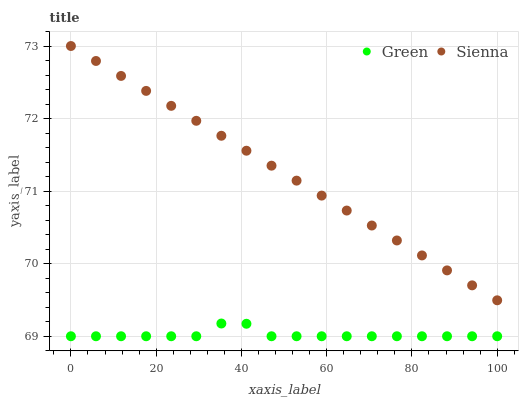Does Green have the minimum area under the curve?
Answer yes or no. Yes. Does Sienna have the maximum area under the curve?
Answer yes or no. Yes. Does Green have the maximum area under the curve?
Answer yes or no. No. Is Sienna the smoothest?
Answer yes or no. Yes. Is Green the roughest?
Answer yes or no. Yes. Is Green the smoothest?
Answer yes or no. No. Does Green have the lowest value?
Answer yes or no. Yes. Does Sienna have the highest value?
Answer yes or no. Yes. Does Green have the highest value?
Answer yes or no. No. Is Green less than Sienna?
Answer yes or no. Yes. Is Sienna greater than Green?
Answer yes or no. Yes. Does Green intersect Sienna?
Answer yes or no. No. 